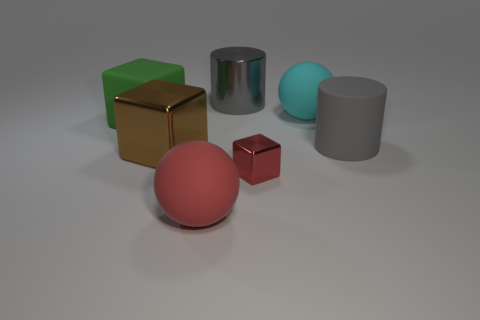Subtract all cyan spheres. Subtract all red blocks. How many spheres are left? 1 Add 1 green metallic cylinders. How many objects exist? 8 Subtract all cylinders. How many objects are left? 5 Add 3 balls. How many balls are left? 5 Add 1 big brown metal spheres. How many big brown metal spheres exist? 1 Subtract 0 purple spheres. How many objects are left? 7 Subtract all small red cubes. Subtract all large cyan matte balls. How many objects are left? 5 